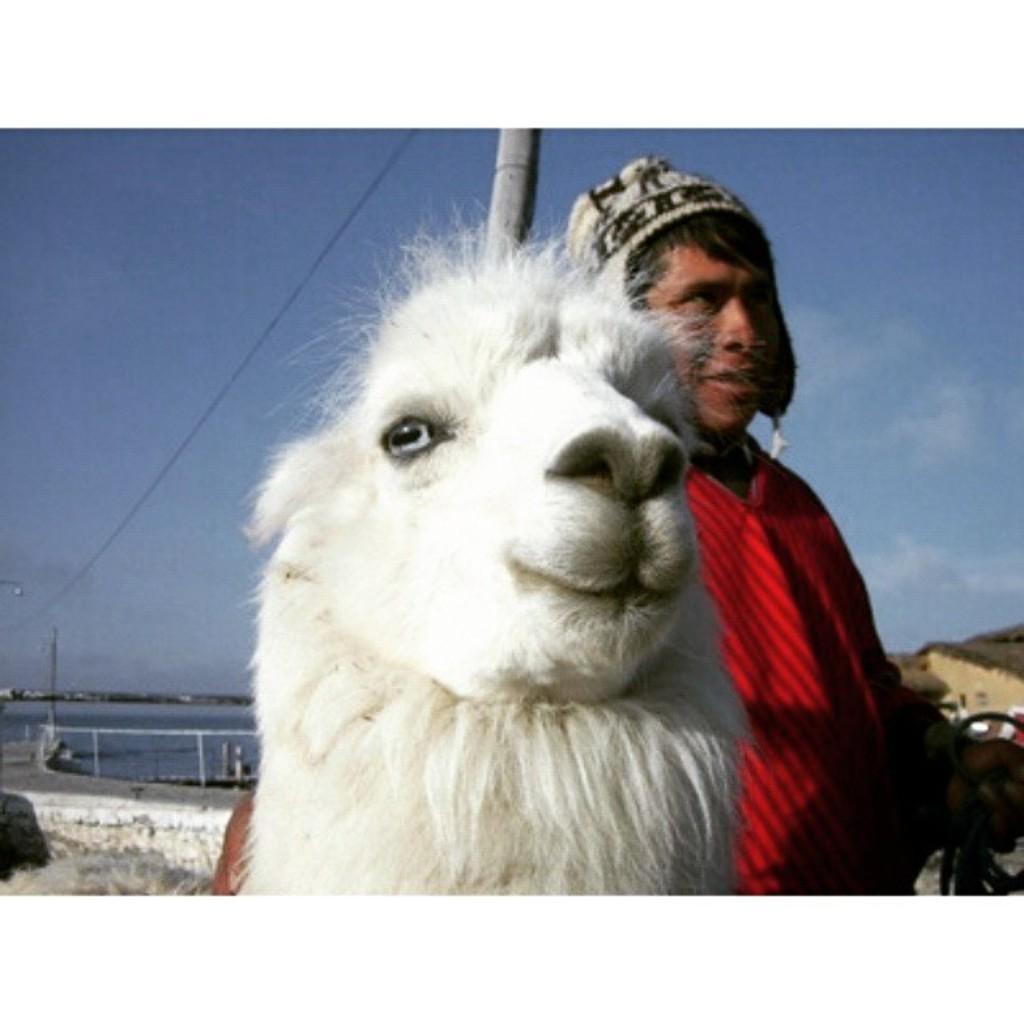How would you summarize this image in a sentence or two? In this image I can see in the middle there is a white color sheep, beside it, there is a person. This person is wearing a red color sweater, at the top it is the sky. 